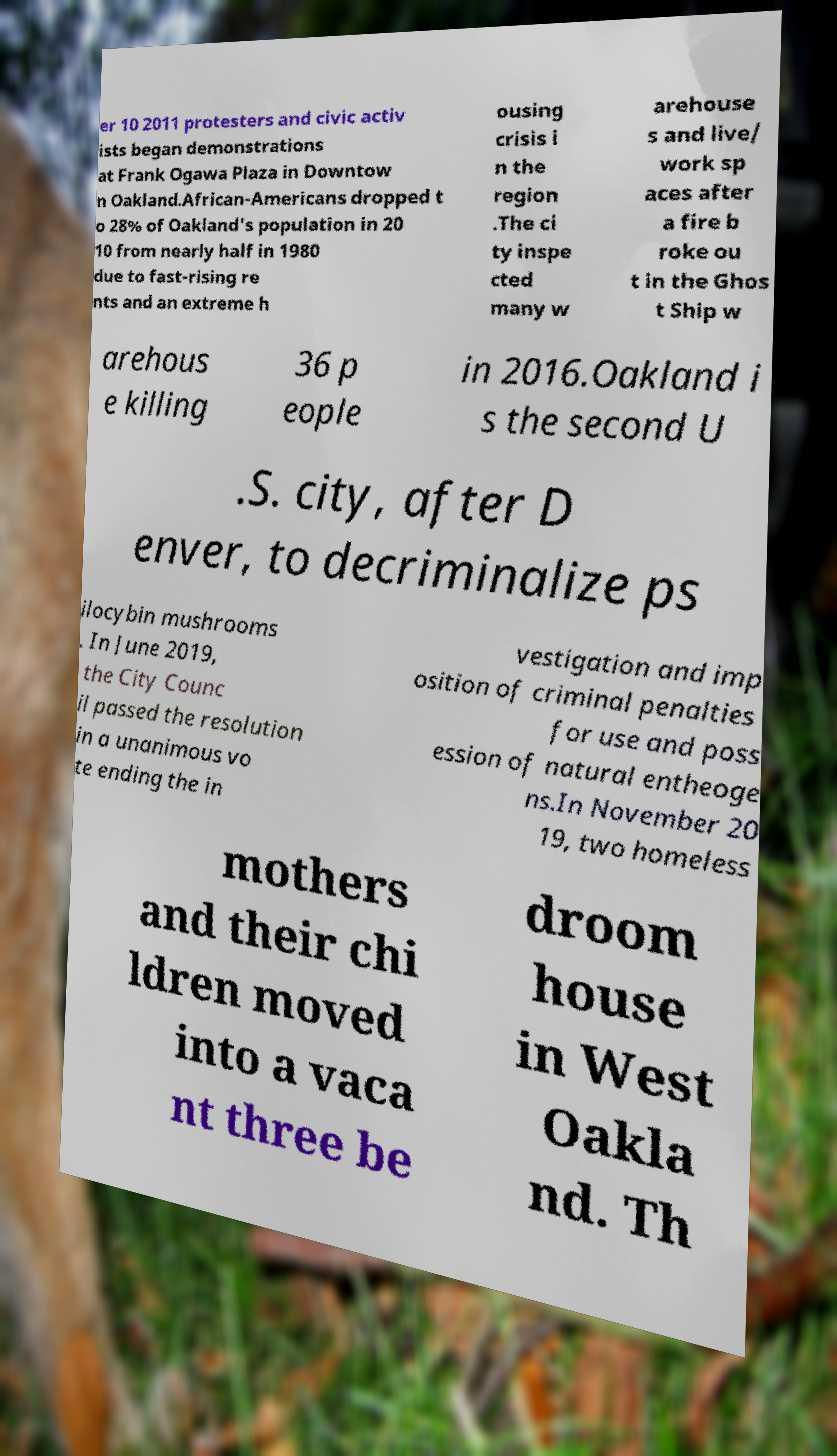What messages or text are displayed in this image? I need them in a readable, typed format. er 10 2011 protesters and civic activ ists began demonstrations at Frank Ogawa Plaza in Downtow n Oakland.African-Americans dropped t o 28% of Oakland's population in 20 10 from nearly half in 1980 due to fast-rising re nts and an extreme h ousing crisis i n the region .The ci ty inspe cted many w arehouse s and live/ work sp aces after a fire b roke ou t in the Ghos t Ship w arehous e killing 36 p eople in 2016.Oakland i s the second U .S. city, after D enver, to decriminalize ps ilocybin mushrooms . In June 2019, the City Counc il passed the resolution in a unanimous vo te ending the in vestigation and imp osition of criminal penalties for use and poss ession of natural entheoge ns.In November 20 19, two homeless mothers and their chi ldren moved into a vaca nt three be droom house in West Oakla nd. Th 